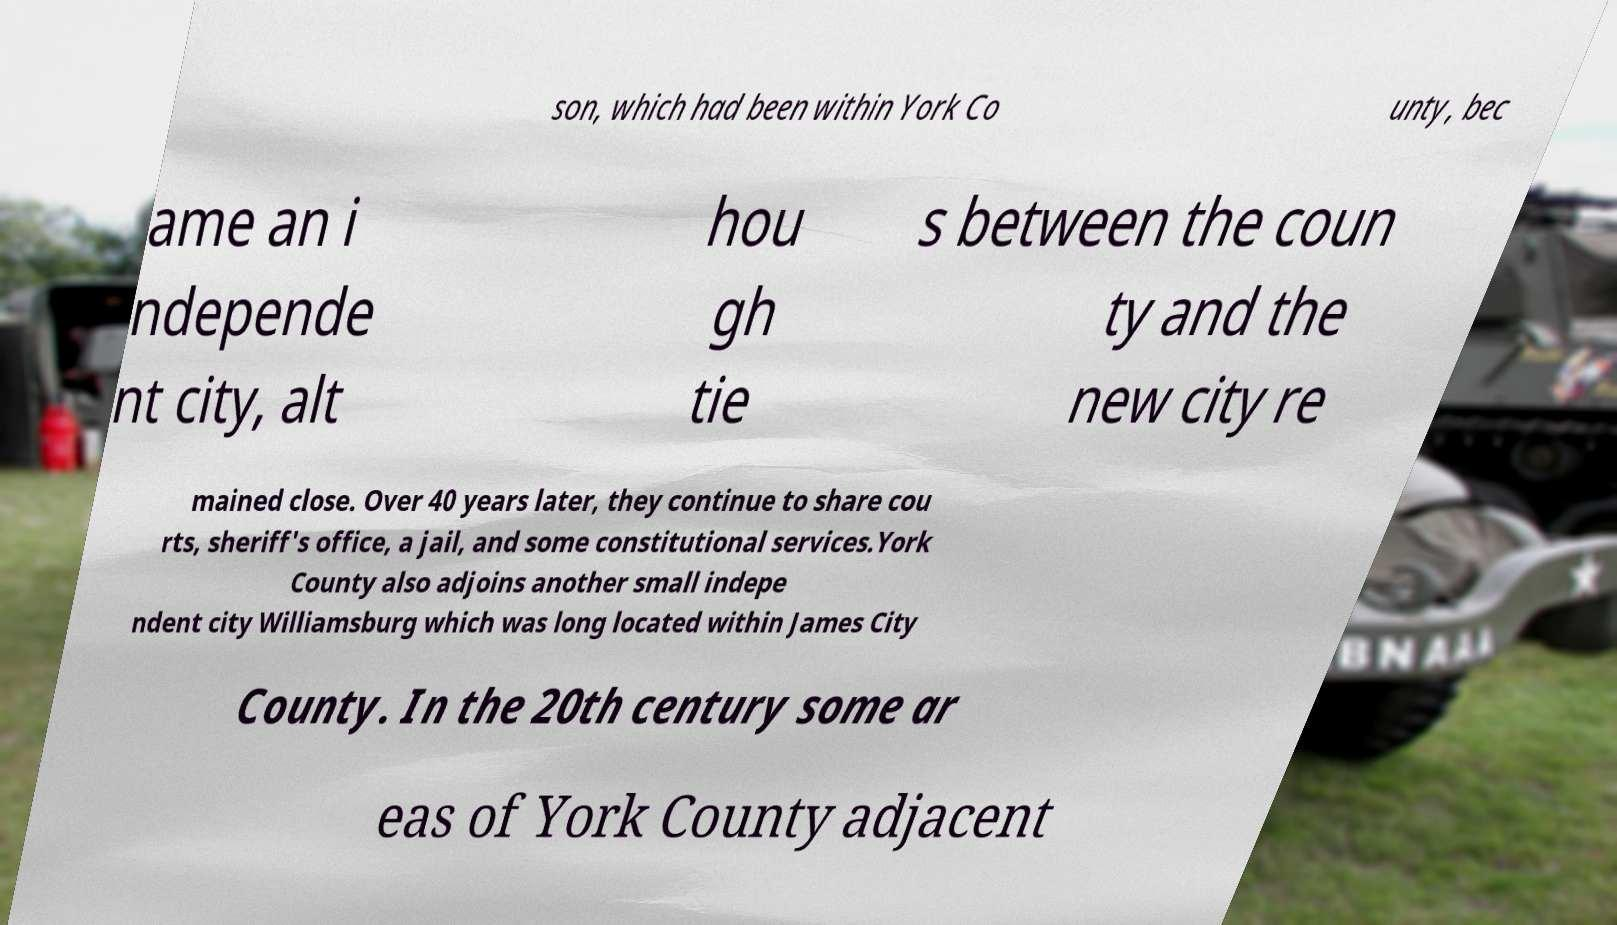Please read and relay the text visible in this image. What does it say? son, which had been within York Co unty, bec ame an i ndepende nt city, alt hou gh tie s between the coun ty and the new city re mained close. Over 40 years later, they continue to share cou rts, sheriff's office, a jail, and some constitutional services.York County also adjoins another small indepe ndent city Williamsburg which was long located within James City County. In the 20th century some ar eas of York County adjacent 